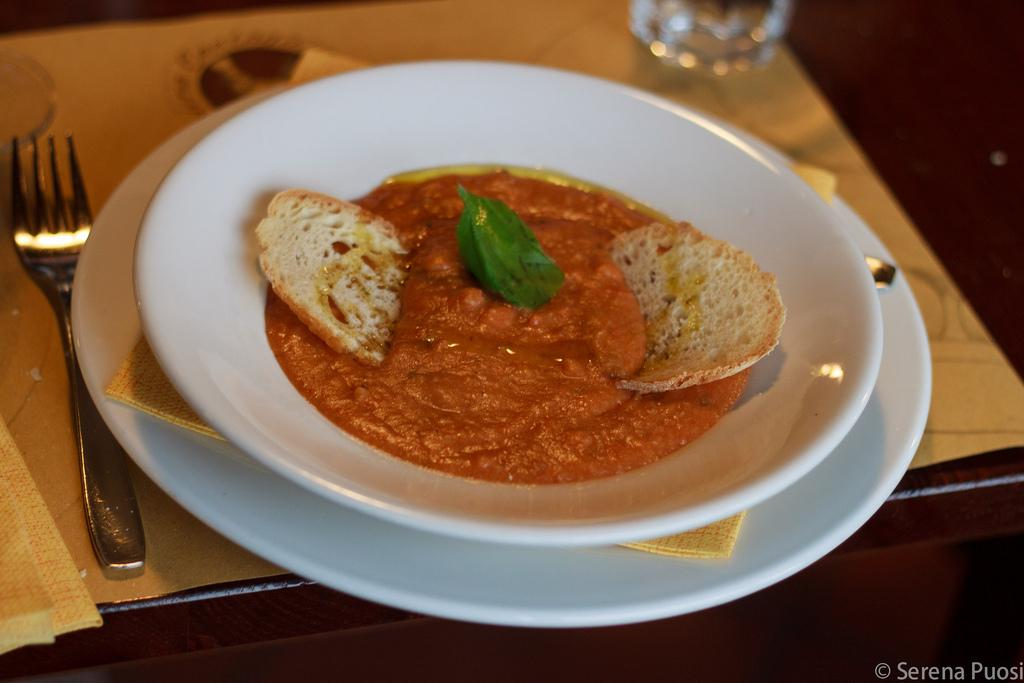What is on the plate that is visible in the image? The plate contains sauce and breads. Besides the plate, what other items can be seen in the image? There is a fork and glasses visible in the background of the image. Where is the image likely taken? The image is likely taken in a room. What type of winter clothing is the spy wearing in the image? There is no spy or winter clothing present in the image. How does the person in the image say good-bye to the viewers? The image does not show a person saying good-bye to the viewers. 